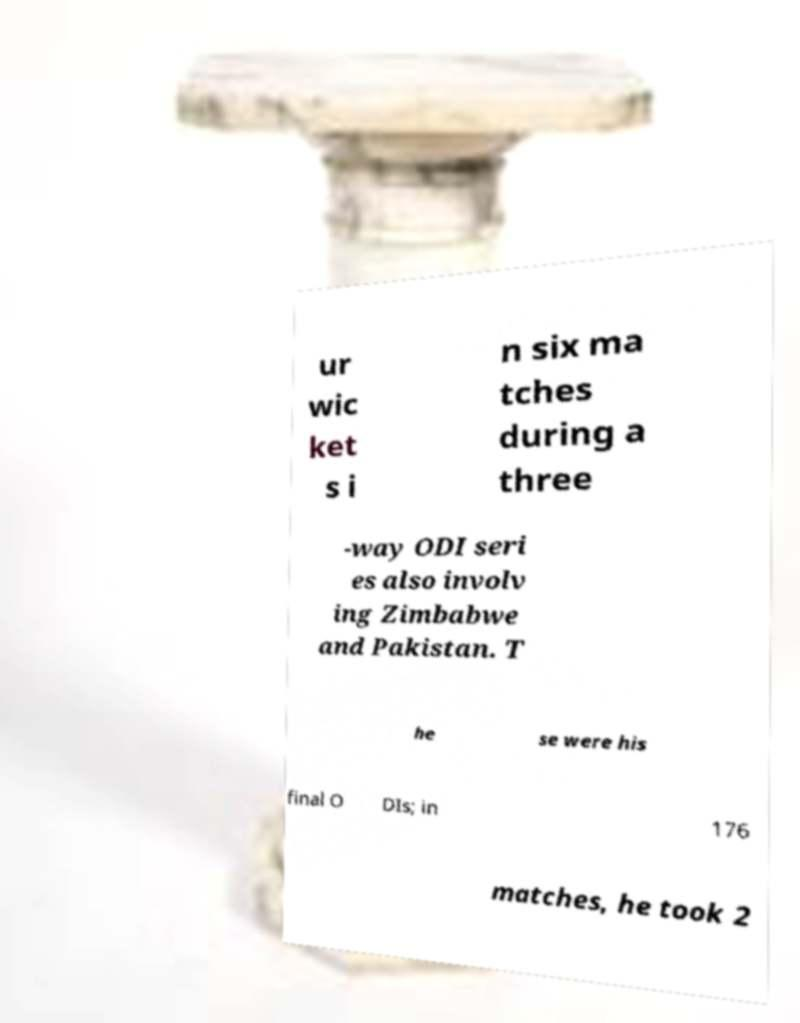For documentation purposes, I need the text within this image transcribed. Could you provide that? ur wic ket s i n six ma tches during a three -way ODI seri es also involv ing Zimbabwe and Pakistan. T he se were his final O DIs; in 176 matches, he took 2 